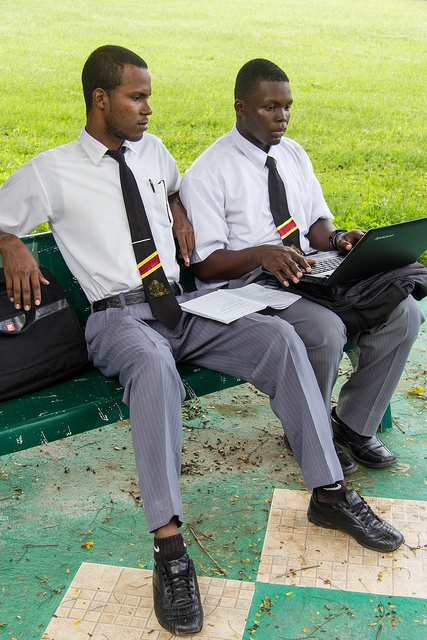Describe the objects in this image and their specific colors. I can see people in khaki, lightgray, gray, black, and darkgray tones, people in khaki, lavender, gray, black, and maroon tones, bench in khaki, black, darkgreen, and teal tones, handbag in khaki, black, gray, darkgray, and maroon tones, and laptop in khaki, black, darkgreen, darkgray, and gray tones in this image. 